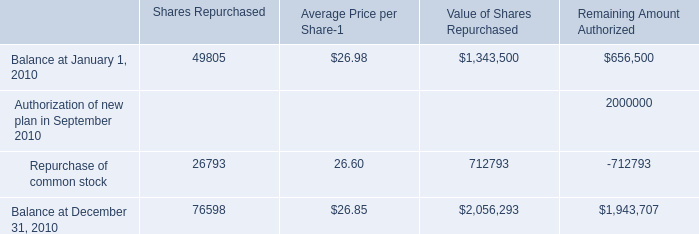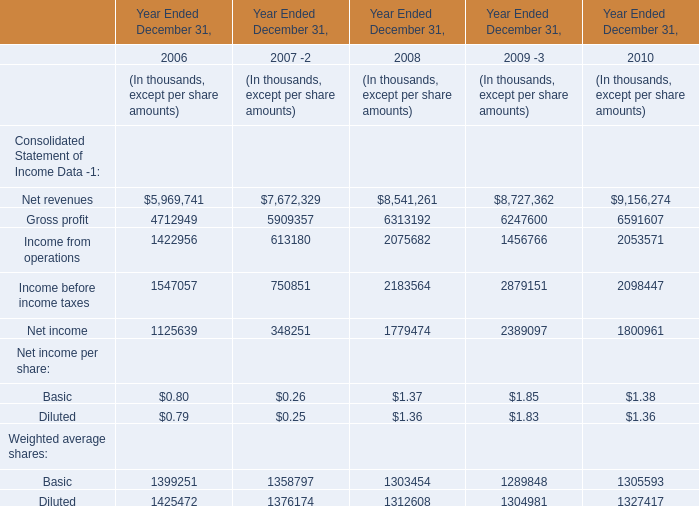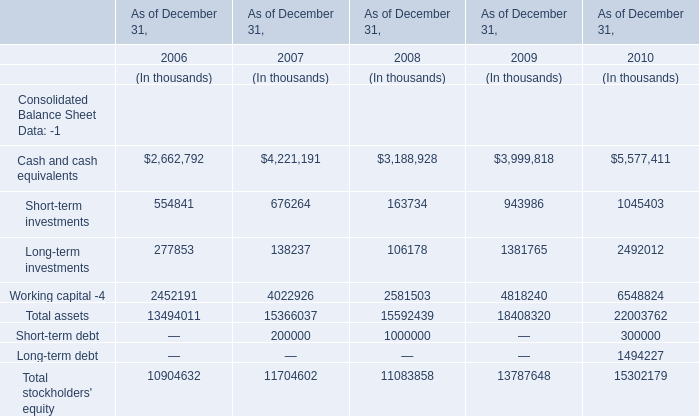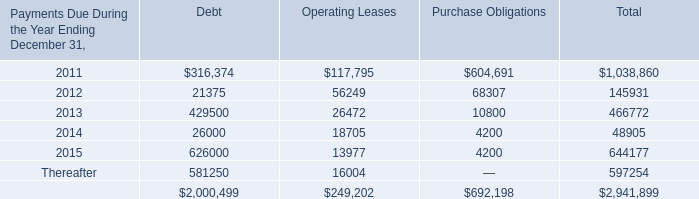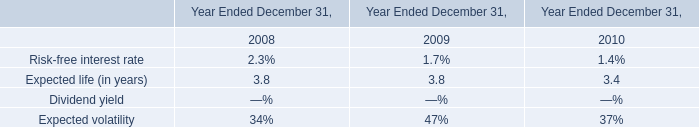What is the sum of net revenues, gross profit and income from operations in 2010? (in thousand) 
Computations: ((9156274 + 6591607) + 2053571)
Answer: 17801452.0. 